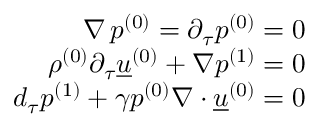Convert formula to latex. <formula><loc_0><loc_0><loc_500><loc_500>\begin{array} { r } { \nabla \, { p ^ { ( 0 ) } } = \partial _ { \tau } { p ^ { ( 0 ) } } = 0 } \\ { { \rho ^ { ( 0 ) } } \partial _ { \tau } { \underline { u } ^ { ( 0 ) } } + \nabla { p ^ { ( 1 ) } } = 0 } \\ { d _ { \tau } { p ^ { ( 1 ) } } + \gamma { p ^ { ( 0 ) } } \nabla { \cdot } { \underline { u } ^ { ( 0 ) } } = 0 } \end{array}</formula> 